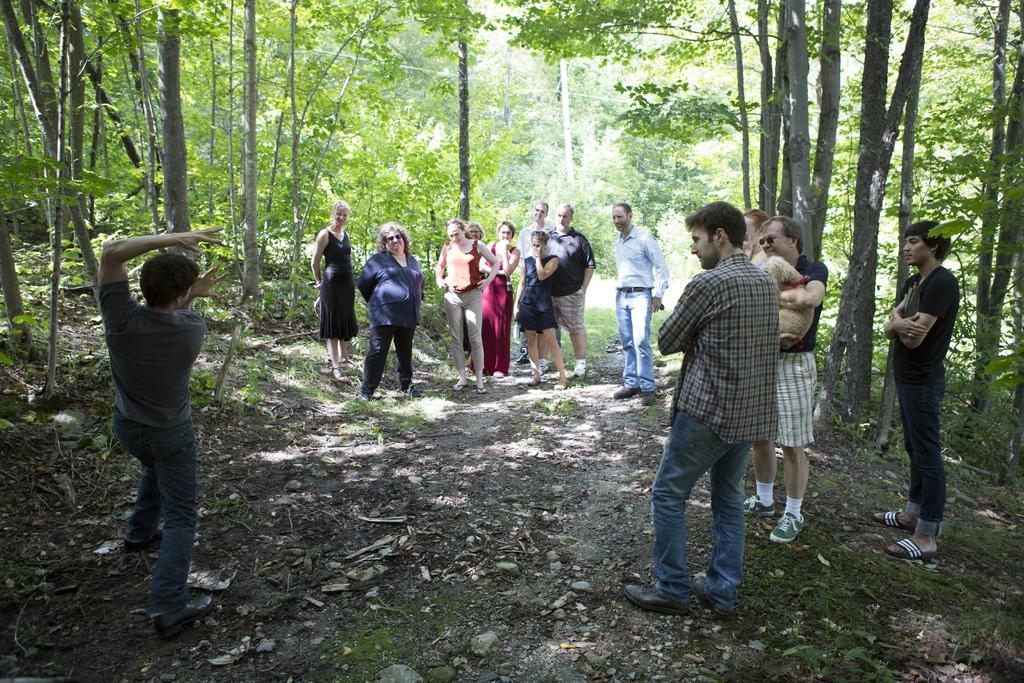Can you describe this image briefly? On the left side of the image we can see a person is explaining something with his hands. In the middle of the image we can see groups of people are standing and listening to the opposite person. On the right side of the image we can see four people are standing and listening to opposite person and one person is holding an animal in his hands. 